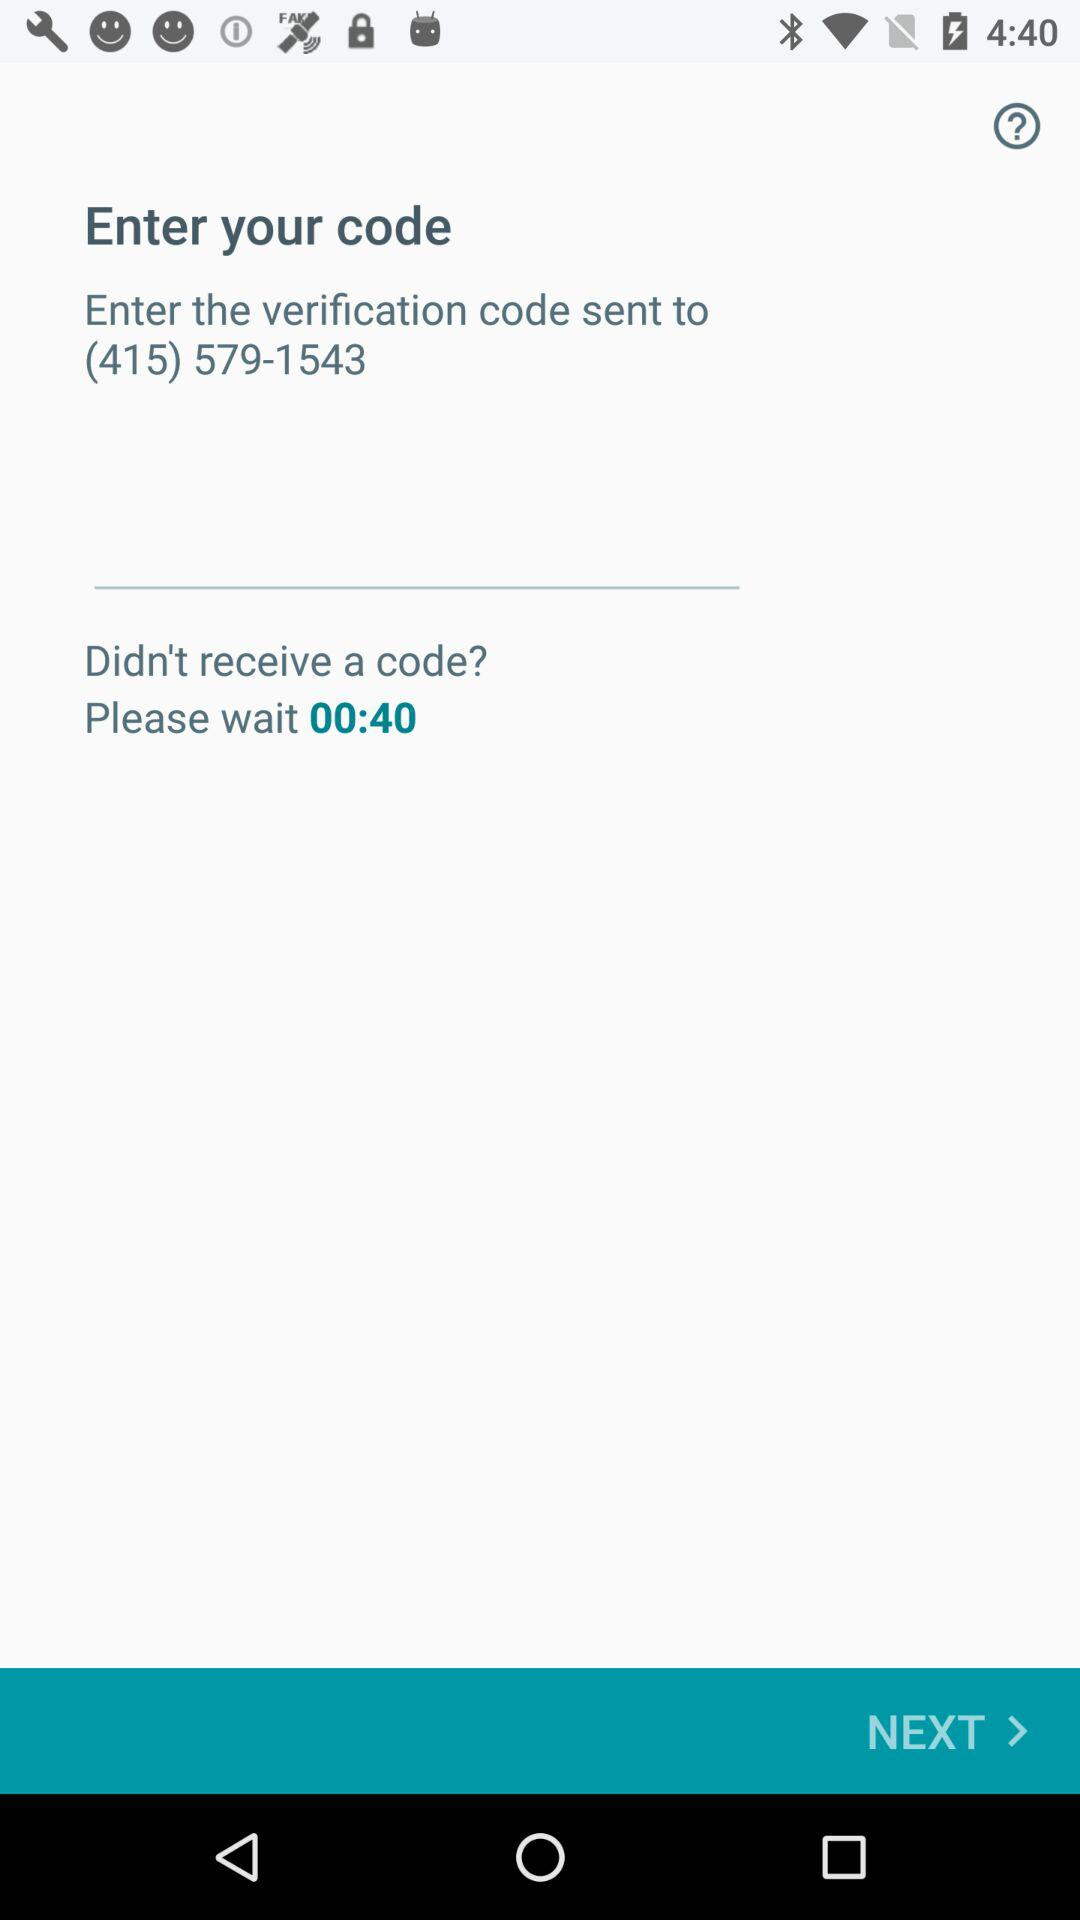How many seconds are left on the timer?
Answer the question using a single word or phrase. 40 